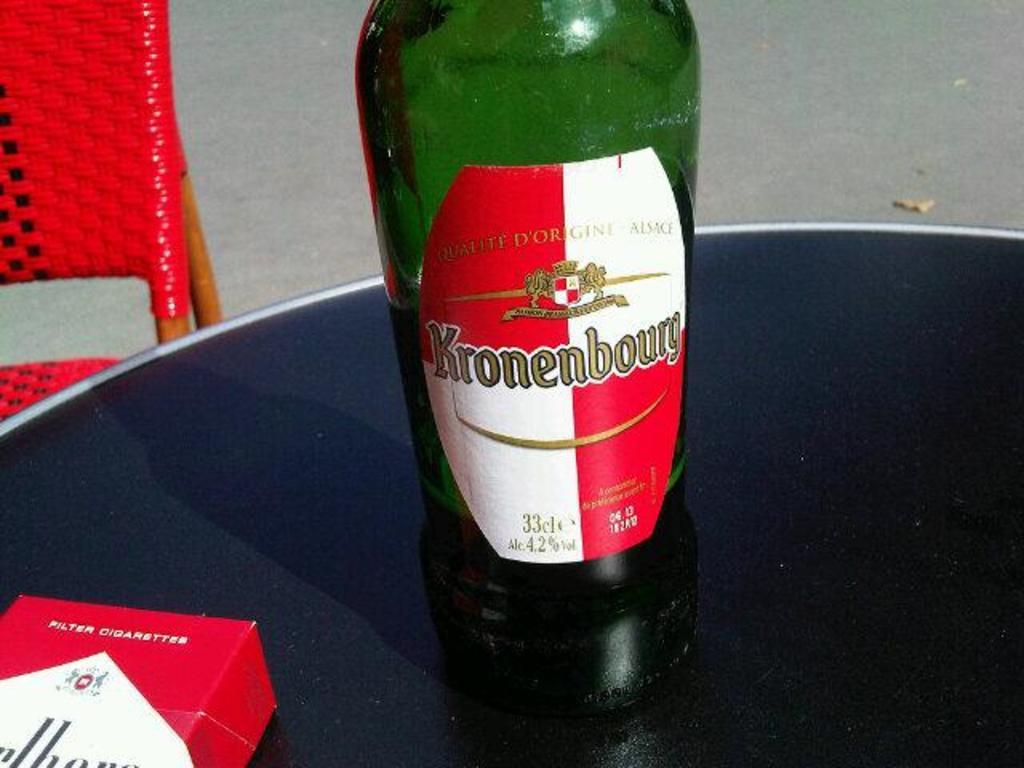What is the name of this drink?
Provide a short and direct response. Kronenbourg. What percent alcohol does this contain?
Provide a succinct answer. 4.2. 